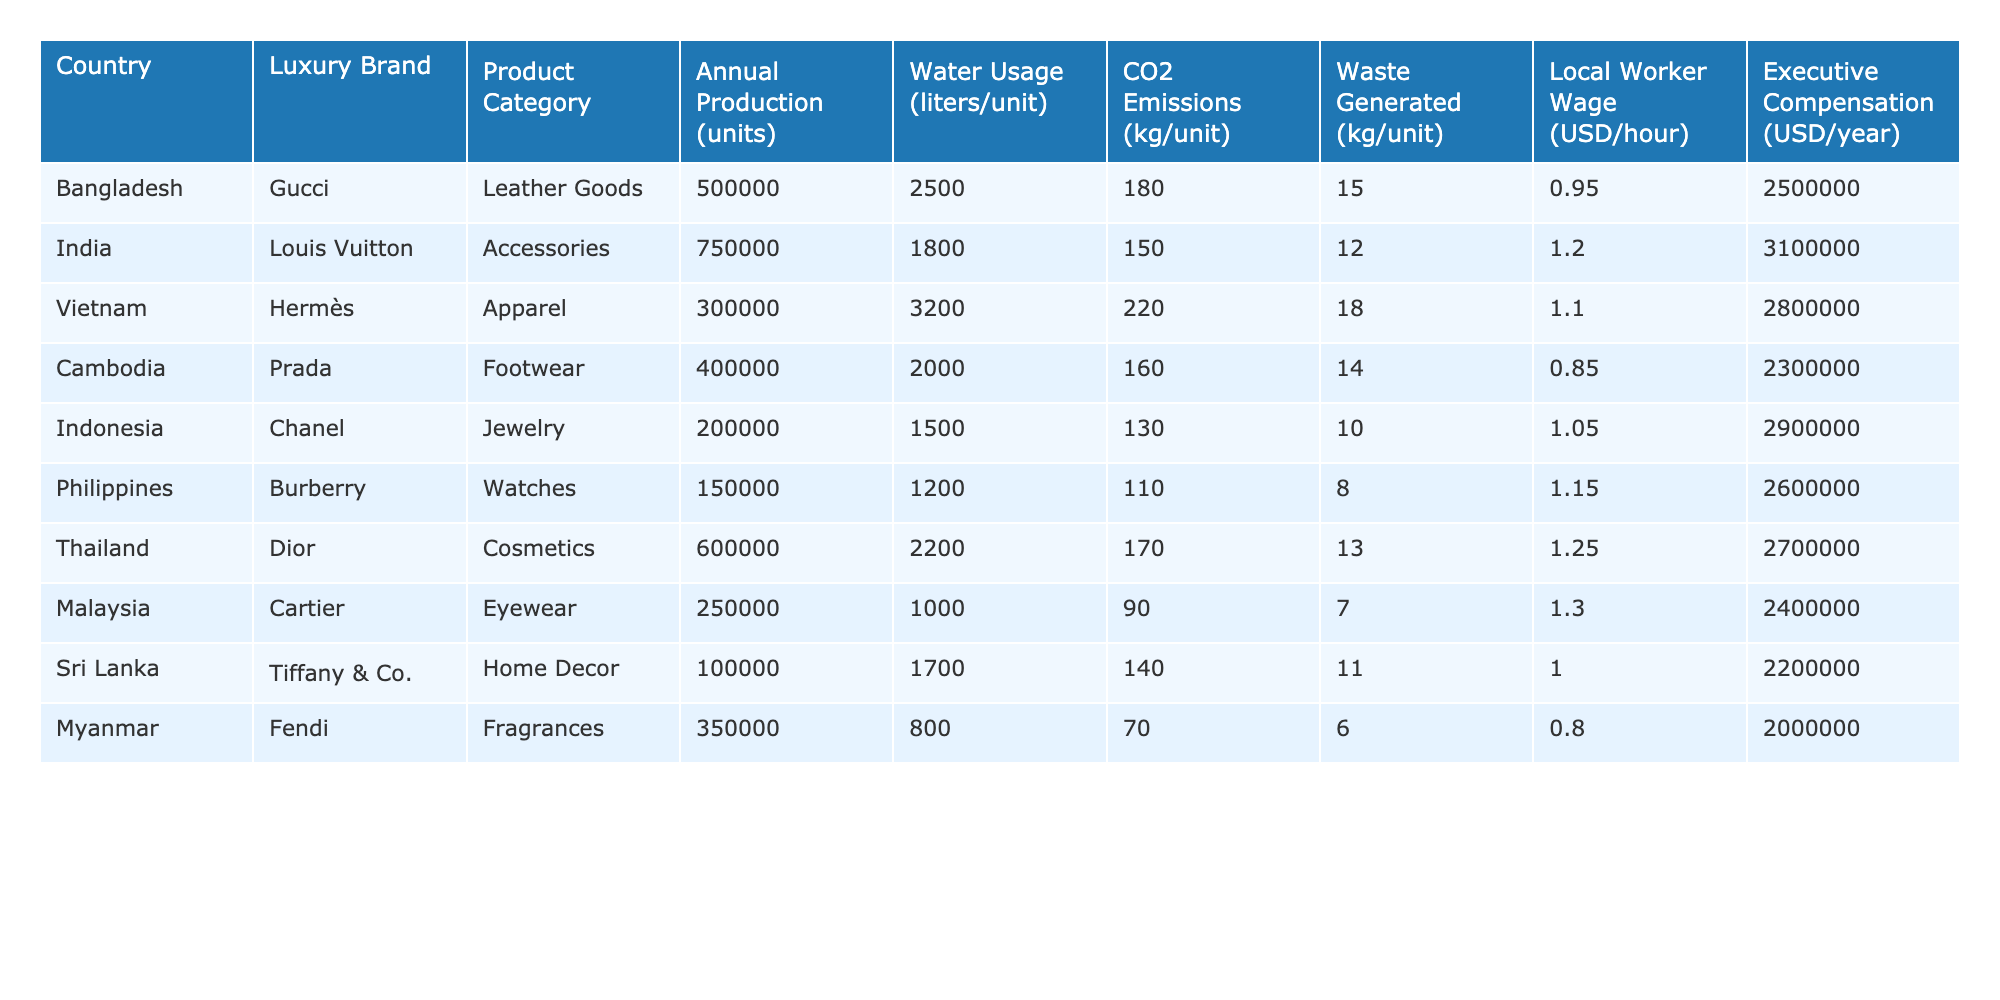What country has the highest annual production of luxury goods? By examining the "Annual Production (units)" column, Bangladesh has the highest production at 500,000 units for Gucci leather goods.
Answer: Bangladesh Which luxury brand has the lowest water usage per unit in the production process? Looking at the "Water Usage (liters/unit)" column, Fendi has the lowest water usage at 800 liters per unit.
Answer: Fendi How much CO2 is emitted on average per unit across all luxury brands listed? First, sum the CO2 emissions: (180 + 150 + 220 + 160 + 130 + 110 + 170 + 90 + 140 + 70) = 1,450 kg. Then, divide by the number of brands: 1,450 kg / 10 = 145 kg.
Answer: 145 kg Is the average wage of local workers in the table higher than $1 per hour? Calculate the average of the "Local Worker Wage (USD/hour)" column: (0.95 + 1.20 + 1.10 + 0.85 + 1.05 + 1.15 + 1.25 + 1.30 + 1.00 + 0.80) / 10 = 1.045, which is above $1.
Answer: Yes What is the total waste generated by all luxury brands listed in the table? Sum the waste generated: (15 + 12 + 18 + 14 + 10 + 8 + 13 + 7 + 11 + 6) = 124 kg.
Answer: 124 kg For which country does the luxury brand produce the most emissions per unit? The highest CO2 emissions per unit is from Vietnam's Hermès, which emits 220 kg/unit.
Answer: Vietnam What is the total executive compensation paid out by all luxury brands combined? Sum the executive compensations: 2,500,000 + 3,100,000 + 2,800,000 + 2,300,000 + 2,900,000 + 2,600,000 + 2,700,000 + 2,400,000 + 2,200,000 + 2,000,000 = 28,100,000 USD.
Answer: 28,100,000 USD What percentage of waste does Bangladesh produce compared to the total waste generated? Bangladesh generates 15 kg of waste. The total waste from previous calculations is 124 kg. The percentage is (15 / 124) * 100 = 12.1%.
Answer: 12.1% Which country has the highest executive compensation, and what is that amount? By checking the "Executive Compensation (USD/year)" column, India has the highest compensation at 3,100,000 USD.
Answer: India, 3,100,000 USD Does any country produce luxury goods with less than 1,000 liters of water usage per unit? Since all listed brands have water usage above 800 liters, there are no countries producing with less than 1,000 liters per unit.
Answer: No 